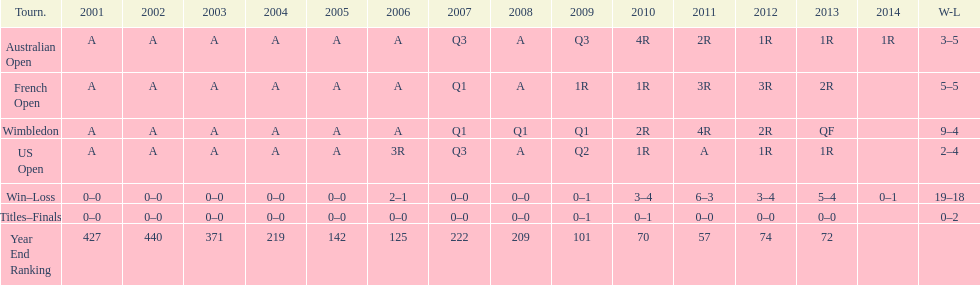In what year was the best year end ranking achieved? 2011. 